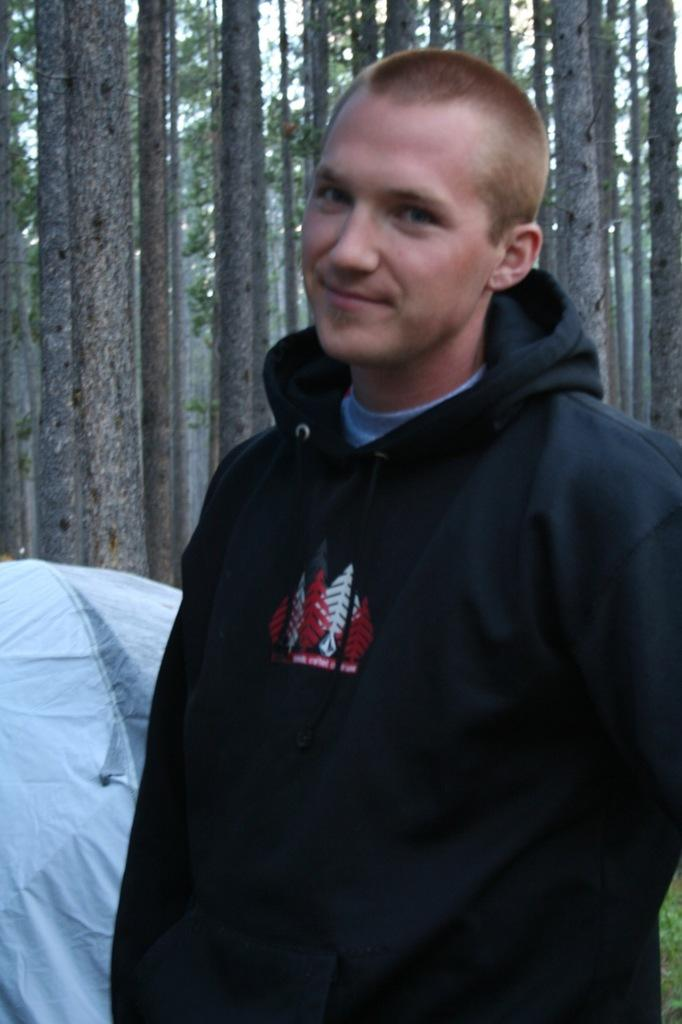Where was the image taken? The image was taken outdoors. What can be seen in the background of the image? There are trees with leaves and branches in the background. What structure is present in the image? There is a tent in the image. Can you describe the person in the image? A man is standing on the right side of the image. How many jellyfish are swimming in the air in the image? There are no jellyfish present in the image, and the image does not depict any swimming creatures in the air. 